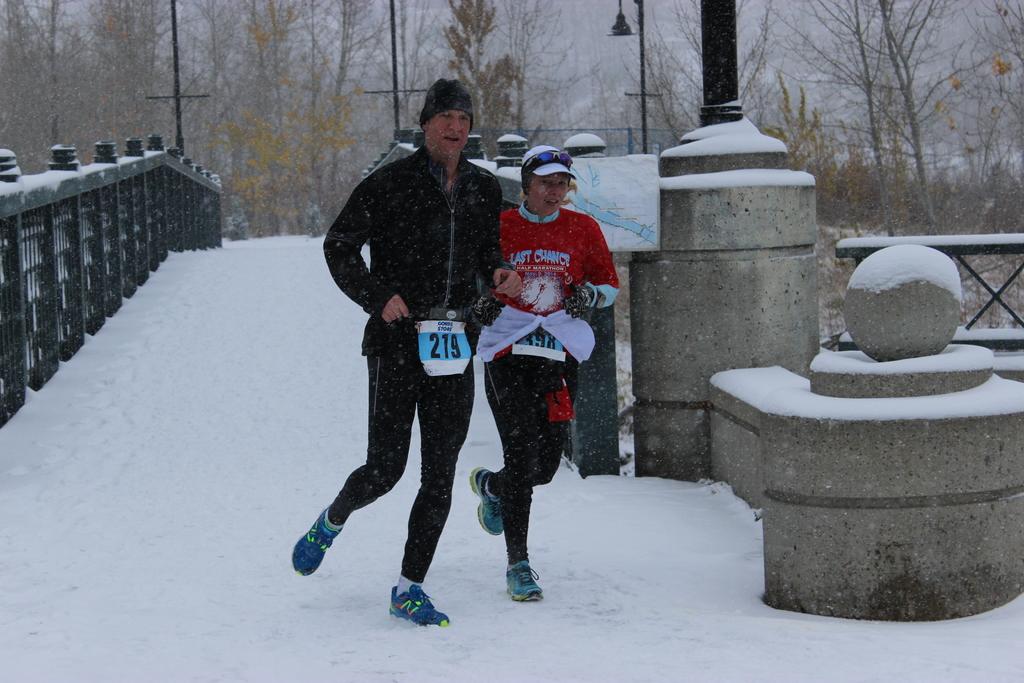What is the man's running number?
Make the answer very short. 219. 